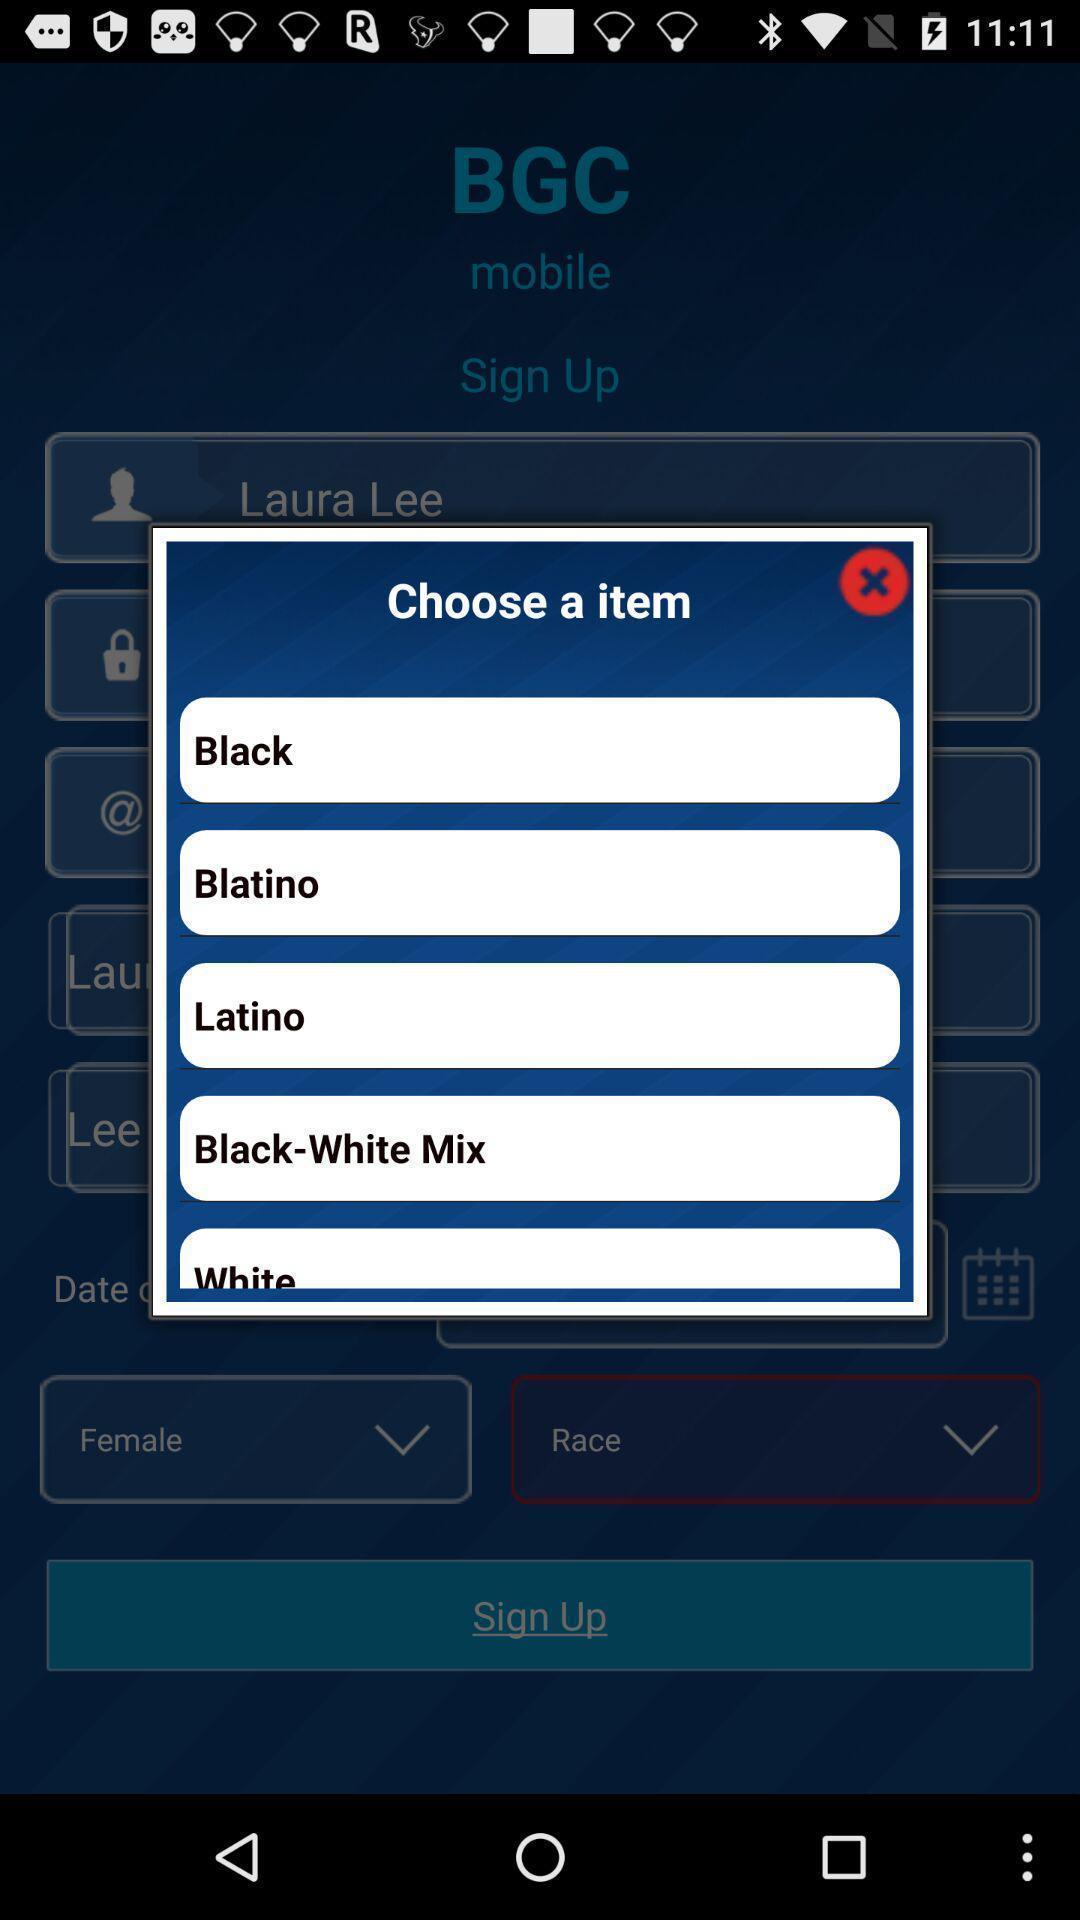Please provide a description for this image. Popup to choose a item. 